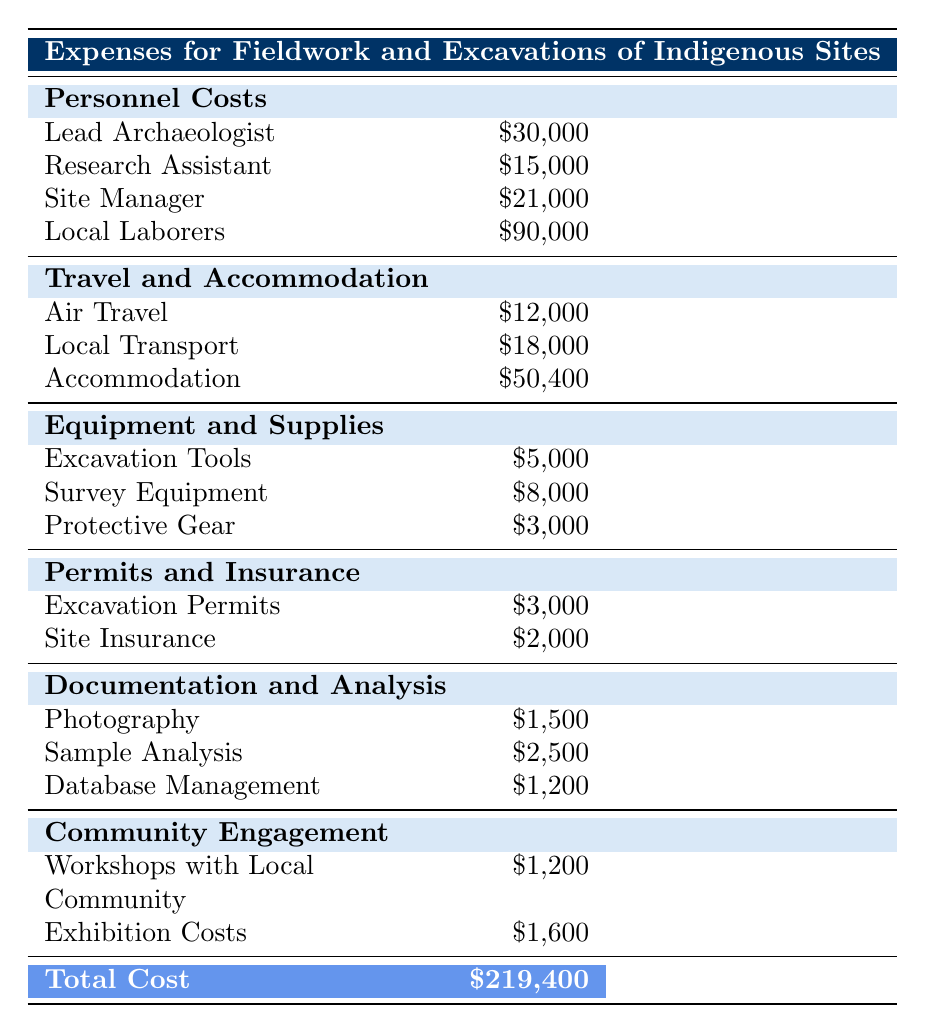What is the total cost for Local Laborers? The cost for Local Laborers is calculated by multiplying the daily wage of 50 USD by the number of laborers (10) and the total workdays (180). So, it's 50 * 10 * 180 = 90,000 USD.
Answer: 90,000 USD How much is spent on Equipment and Supplies in total? To find the total for Equipment and Supplies, we add the costs of Excavation Tools (5,000 USD), Survey Equipment (8,000 USD), and Protective Gear (3,000 USD): 5,000 + 8,000 + 3,000 = 16,000 USD.
Answer: 16,000 USD Is the cost for Accommodation higher than the total of Air Travel and Local Transport? The cost for Accommodation is 50,400 USD. The total for Air Travel (12,000 USD) and Local Transport (18,000 USD) is 12,000 + 18,000 = 30,000 USD. Since 50,400 USD is greater than 30,000 USD, the answer is yes.
Answer: Yes What is the combined cost of Photography and Sample Analysis? To find the combined cost, we add the costs of Photography (1,500 USD) and Sample Analysis (2,500 USD): 1,500 + 2,500 = 4,000 USD.
Answer: 4,000 USD What percentage of the total expenses does Documentation and Analysis represent? The total cost for Documentation and Analysis includes Photography (1,500 USD), Sample Analysis (2,500 USD), and Database Management (1,200 USD), summing to 1,500 + 2,500 + 1,200 = 5,200 USD. To find the percentage of the total cost (219,400 USD), we use the formula (5,200 / 219,400) × 100, which gives approximately 2.37%.
Answer: 2.37% What is the cost difference between Local Transport and Accommodation? The cost for Local Transport is 18,000 USD, and for Accommodation, it is 50,400 USD. The difference is calculated as 50,400 - 18,000 = 32,400 USD.
Answer: 32,400 USD Did the costs for Permits and Insurance exceed 5,000 USD? The total for Permits and Insurance includes Excavation Permits (3,000 USD) and Site Insurance (2,000 USD), totaling 5,000 USD. Since it does not exceed 5,000 USD, the answer is no.
Answer: No What is the average monthly salary of all personnel costs? The total personnel costs include Lead Archaeologist (30,000 USD), Research Assistant (15,000 USD), Site Manager (21,000 USD), and Local Laborers (90,000 USD). The total is 30,000 + 15,000 + 21,000 + 90,000 = 156,000 USD. There are four roles, so the average monthly salary is 156,000 / 4 = 39,000 USD.
Answer: 39,000 USD 